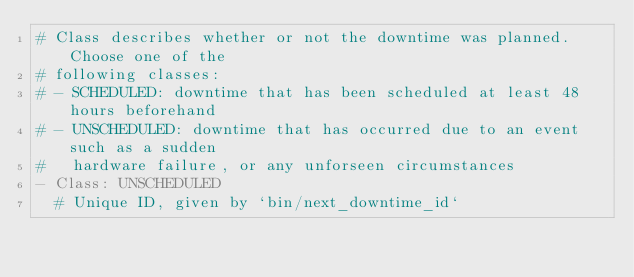Convert code to text. <code><loc_0><loc_0><loc_500><loc_500><_YAML_># Class describes whether or not the downtime was planned. Choose one of the
# following classes:
# - SCHEDULED: downtime that has been scheduled at least 48 hours beforehand
# - UNSCHEDULED: downtime that has occurred due to an event such as a sudden
#   hardware failure, or any unforseen circumstances
- Class: UNSCHEDULED
  # Unique ID, given by `bin/next_downtime_id`</code> 